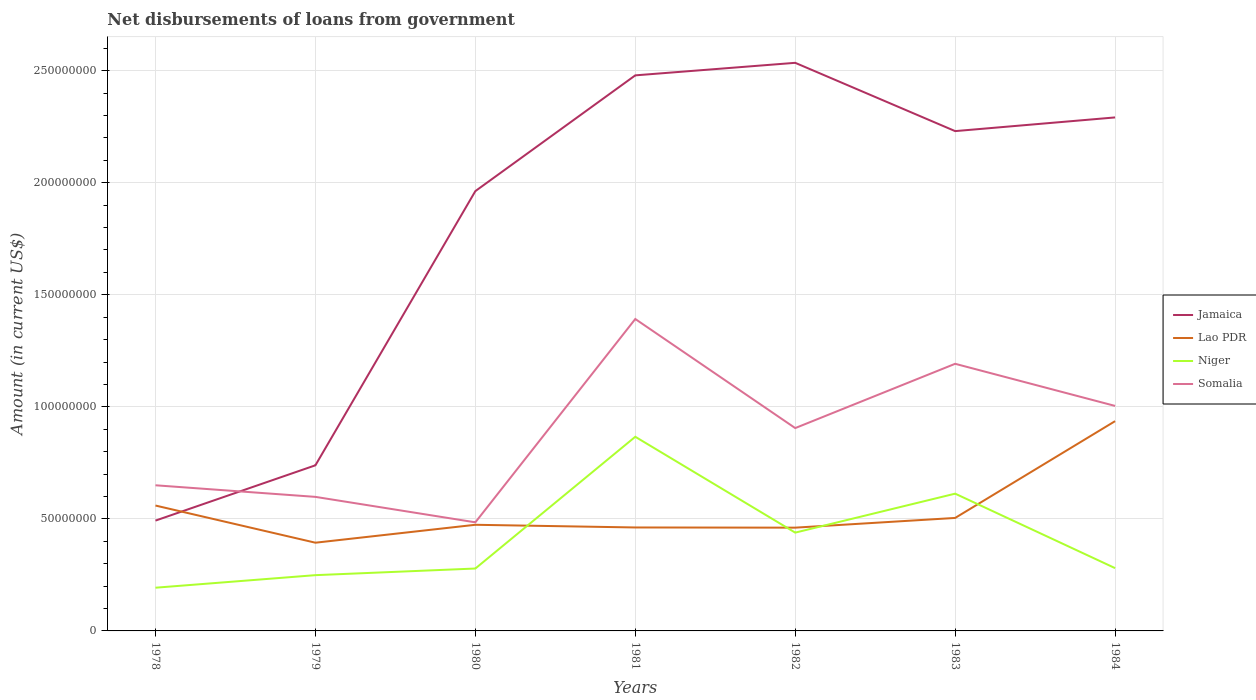Is the number of lines equal to the number of legend labels?
Offer a terse response. Yes. Across all years, what is the maximum amount of loan disbursed from government in Jamaica?
Your response must be concise. 4.92e+07. In which year was the amount of loan disbursed from government in Somalia maximum?
Give a very brief answer. 1980. What is the total amount of loan disbursed from government in Niger in the graph?
Make the answer very short. -1.60e+07. What is the difference between the highest and the second highest amount of loan disbursed from government in Niger?
Ensure brevity in your answer.  6.74e+07. What is the difference between the highest and the lowest amount of loan disbursed from government in Lao PDR?
Provide a succinct answer. 2. What is the difference between two consecutive major ticks on the Y-axis?
Offer a terse response. 5.00e+07. Does the graph contain any zero values?
Offer a terse response. No. Does the graph contain grids?
Offer a terse response. Yes. Where does the legend appear in the graph?
Your answer should be compact. Center right. How many legend labels are there?
Provide a short and direct response. 4. What is the title of the graph?
Offer a terse response. Net disbursements of loans from government. What is the label or title of the X-axis?
Your answer should be compact. Years. What is the Amount (in current US$) of Jamaica in 1978?
Ensure brevity in your answer.  4.92e+07. What is the Amount (in current US$) of Lao PDR in 1978?
Give a very brief answer. 5.60e+07. What is the Amount (in current US$) of Niger in 1978?
Ensure brevity in your answer.  1.93e+07. What is the Amount (in current US$) in Somalia in 1978?
Ensure brevity in your answer.  6.50e+07. What is the Amount (in current US$) in Jamaica in 1979?
Give a very brief answer. 7.39e+07. What is the Amount (in current US$) of Lao PDR in 1979?
Give a very brief answer. 3.94e+07. What is the Amount (in current US$) in Niger in 1979?
Provide a short and direct response. 2.49e+07. What is the Amount (in current US$) in Somalia in 1979?
Make the answer very short. 5.98e+07. What is the Amount (in current US$) of Jamaica in 1980?
Your answer should be very brief. 1.96e+08. What is the Amount (in current US$) in Lao PDR in 1980?
Offer a terse response. 4.74e+07. What is the Amount (in current US$) in Niger in 1980?
Give a very brief answer. 2.78e+07. What is the Amount (in current US$) of Somalia in 1980?
Keep it short and to the point. 4.85e+07. What is the Amount (in current US$) of Jamaica in 1981?
Keep it short and to the point. 2.48e+08. What is the Amount (in current US$) in Lao PDR in 1981?
Give a very brief answer. 4.62e+07. What is the Amount (in current US$) in Niger in 1981?
Provide a short and direct response. 8.66e+07. What is the Amount (in current US$) of Somalia in 1981?
Provide a short and direct response. 1.39e+08. What is the Amount (in current US$) in Jamaica in 1982?
Provide a succinct answer. 2.54e+08. What is the Amount (in current US$) of Lao PDR in 1982?
Make the answer very short. 4.61e+07. What is the Amount (in current US$) of Niger in 1982?
Ensure brevity in your answer.  4.39e+07. What is the Amount (in current US$) of Somalia in 1982?
Your answer should be very brief. 9.05e+07. What is the Amount (in current US$) in Jamaica in 1983?
Offer a very short reply. 2.23e+08. What is the Amount (in current US$) in Lao PDR in 1983?
Your answer should be very brief. 5.04e+07. What is the Amount (in current US$) of Niger in 1983?
Keep it short and to the point. 6.13e+07. What is the Amount (in current US$) in Somalia in 1983?
Offer a very short reply. 1.19e+08. What is the Amount (in current US$) in Jamaica in 1984?
Offer a terse response. 2.29e+08. What is the Amount (in current US$) in Lao PDR in 1984?
Keep it short and to the point. 9.36e+07. What is the Amount (in current US$) in Niger in 1984?
Offer a very short reply. 2.80e+07. What is the Amount (in current US$) in Somalia in 1984?
Your answer should be very brief. 1.00e+08. Across all years, what is the maximum Amount (in current US$) in Jamaica?
Your response must be concise. 2.54e+08. Across all years, what is the maximum Amount (in current US$) in Lao PDR?
Provide a succinct answer. 9.36e+07. Across all years, what is the maximum Amount (in current US$) in Niger?
Give a very brief answer. 8.66e+07. Across all years, what is the maximum Amount (in current US$) in Somalia?
Provide a short and direct response. 1.39e+08. Across all years, what is the minimum Amount (in current US$) of Jamaica?
Provide a short and direct response. 4.92e+07. Across all years, what is the minimum Amount (in current US$) in Lao PDR?
Offer a terse response. 3.94e+07. Across all years, what is the minimum Amount (in current US$) in Niger?
Offer a very short reply. 1.93e+07. Across all years, what is the minimum Amount (in current US$) in Somalia?
Ensure brevity in your answer.  4.85e+07. What is the total Amount (in current US$) in Jamaica in the graph?
Your response must be concise. 1.27e+09. What is the total Amount (in current US$) in Lao PDR in the graph?
Keep it short and to the point. 3.79e+08. What is the total Amount (in current US$) of Niger in the graph?
Offer a very short reply. 2.92e+08. What is the total Amount (in current US$) in Somalia in the graph?
Ensure brevity in your answer.  6.23e+08. What is the difference between the Amount (in current US$) of Jamaica in 1978 and that in 1979?
Keep it short and to the point. -2.47e+07. What is the difference between the Amount (in current US$) in Lao PDR in 1978 and that in 1979?
Keep it short and to the point. 1.66e+07. What is the difference between the Amount (in current US$) in Niger in 1978 and that in 1979?
Make the answer very short. -5.60e+06. What is the difference between the Amount (in current US$) of Somalia in 1978 and that in 1979?
Offer a terse response. 5.17e+06. What is the difference between the Amount (in current US$) in Jamaica in 1978 and that in 1980?
Keep it short and to the point. -1.47e+08. What is the difference between the Amount (in current US$) of Lao PDR in 1978 and that in 1980?
Your answer should be compact. 8.59e+06. What is the difference between the Amount (in current US$) in Niger in 1978 and that in 1980?
Provide a short and direct response. -8.56e+06. What is the difference between the Amount (in current US$) of Somalia in 1978 and that in 1980?
Your answer should be very brief. 1.65e+07. What is the difference between the Amount (in current US$) in Jamaica in 1978 and that in 1981?
Your answer should be compact. -1.99e+08. What is the difference between the Amount (in current US$) in Lao PDR in 1978 and that in 1981?
Keep it short and to the point. 9.79e+06. What is the difference between the Amount (in current US$) in Niger in 1978 and that in 1981?
Provide a succinct answer. -6.74e+07. What is the difference between the Amount (in current US$) of Somalia in 1978 and that in 1981?
Make the answer very short. -7.42e+07. What is the difference between the Amount (in current US$) of Jamaica in 1978 and that in 1982?
Ensure brevity in your answer.  -2.04e+08. What is the difference between the Amount (in current US$) in Lao PDR in 1978 and that in 1982?
Offer a very short reply. 9.87e+06. What is the difference between the Amount (in current US$) in Niger in 1978 and that in 1982?
Ensure brevity in your answer.  -2.46e+07. What is the difference between the Amount (in current US$) in Somalia in 1978 and that in 1982?
Provide a succinct answer. -2.55e+07. What is the difference between the Amount (in current US$) in Jamaica in 1978 and that in 1983?
Offer a terse response. -1.74e+08. What is the difference between the Amount (in current US$) in Lao PDR in 1978 and that in 1983?
Your answer should be very brief. 5.54e+06. What is the difference between the Amount (in current US$) in Niger in 1978 and that in 1983?
Provide a short and direct response. -4.20e+07. What is the difference between the Amount (in current US$) in Somalia in 1978 and that in 1983?
Ensure brevity in your answer.  -5.42e+07. What is the difference between the Amount (in current US$) of Jamaica in 1978 and that in 1984?
Provide a succinct answer. -1.80e+08. What is the difference between the Amount (in current US$) in Lao PDR in 1978 and that in 1984?
Make the answer very short. -3.77e+07. What is the difference between the Amount (in current US$) in Niger in 1978 and that in 1984?
Provide a succinct answer. -8.74e+06. What is the difference between the Amount (in current US$) in Somalia in 1978 and that in 1984?
Keep it short and to the point. -3.54e+07. What is the difference between the Amount (in current US$) in Jamaica in 1979 and that in 1980?
Offer a terse response. -1.22e+08. What is the difference between the Amount (in current US$) in Lao PDR in 1979 and that in 1980?
Your response must be concise. -8.00e+06. What is the difference between the Amount (in current US$) in Niger in 1979 and that in 1980?
Your answer should be compact. -2.96e+06. What is the difference between the Amount (in current US$) in Somalia in 1979 and that in 1980?
Offer a very short reply. 1.14e+07. What is the difference between the Amount (in current US$) in Jamaica in 1979 and that in 1981?
Make the answer very short. -1.74e+08. What is the difference between the Amount (in current US$) in Lao PDR in 1979 and that in 1981?
Your response must be concise. -6.80e+06. What is the difference between the Amount (in current US$) of Niger in 1979 and that in 1981?
Offer a very short reply. -6.18e+07. What is the difference between the Amount (in current US$) of Somalia in 1979 and that in 1981?
Offer a very short reply. -7.94e+07. What is the difference between the Amount (in current US$) in Jamaica in 1979 and that in 1982?
Keep it short and to the point. -1.80e+08. What is the difference between the Amount (in current US$) in Lao PDR in 1979 and that in 1982?
Make the answer very short. -6.72e+06. What is the difference between the Amount (in current US$) of Niger in 1979 and that in 1982?
Your answer should be compact. -1.90e+07. What is the difference between the Amount (in current US$) of Somalia in 1979 and that in 1982?
Offer a very short reply. -3.07e+07. What is the difference between the Amount (in current US$) of Jamaica in 1979 and that in 1983?
Give a very brief answer. -1.49e+08. What is the difference between the Amount (in current US$) in Lao PDR in 1979 and that in 1983?
Your answer should be compact. -1.11e+07. What is the difference between the Amount (in current US$) of Niger in 1979 and that in 1983?
Give a very brief answer. -3.64e+07. What is the difference between the Amount (in current US$) in Somalia in 1979 and that in 1983?
Provide a succinct answer. -5.94e+07. What is the difference between the Amount (in current US$) in Jamaica in 1979 and that in 1984?
Give a very brief answer. -1.55e+08. What is the difference between the Amount (in current US$) of Lao PDR in 1979 and that in 1984?
Make the answer very short. -5.42e+07. What is the difference between the Amount (in current US$) in Niger in 1979 and that in 1984?
Make the answer very short. -3.14e+06. What is the difference between the Amount (in current US$) in Somalia in 1979 and that in 1984?
Provide a succinct answer. -4.06e+07. What is the difference between the Amount (in current US$) in Jamaica in 1980 and that in 1981?
Provide a succinct answer. -5.17e+07. What is the difference between the Amount (in current US$) of Lao PDR in 1980 and that in 1981?
Offer a very short reply. 1.20e+06. What is the difference between the Amount (in current US$) in Niger in 1980 and that in 1981?
Offer a terse response. -5.88e+07. What is the difference between the Amount (in current US$) in Somalia in 1980 and that in 1981?
Your answer should be very brief. -9.07e+07. What is the difference between the Amount (in current US$) in Jamaica in 1980 and that in 1982?
Make the answer very short. -5.73e+07. What is the difference between the Amount (in current US$) in Lao PDR in 1980 and that in 1982?
Make the answer very short. 1.28e+06. What is the difference between the Amount (in current US$) of Niger in 1980 and that in 1982?
Offer a terse response. -1.60e+07. What is the difference between the Amount (in current US$) in Somalia in 1980 and that in 1982?
Offer a terse response. -4.21e+07. What is the difference between the Amount (in current US$) in Jamaica in 1980 and that in 1983?
Make the answer very short. -2.68e+07. What is the difference between the Amount (in current US$) in Lao PDR in 1980 and that in 1983?
Give a very brief answer. -3.05e+06. What is the difference between the Amount (in current US$) in Niger in 1980 and that in 1983?
Give a very brief answer. -3.34e+07. What is the difference between the Amount (in current US$) of Somalia in 1980 and that in 1983?
Your answer should be very brief. -7.07e+07. What is the difference between the Amount (in current US$) in Jamaica in 1980 and that in 1984?
Provide a short and direct response. -3.29e+07. What is the difference between the Amount (in current US$) in Lao PDR in 1980 and that in 1984?
Ensure brevity in your answer.  -4.62e+07. What is the difference between the Amount (in current US$) in Niger in 1980 and that in 1984?
Offer a very short reply. -1.76e+05. What is the difference between the Amount (in current US$) of Somalia in 1980 and that in 1984?
Ensure brevity in your answer.  -5.19e+07. What is the difference between the Amount (in current US$) in Jamaica in 1981 and that in 1982?
Offer a terse response. -5.60e+06. What is the difference between the Amount (in current US$) of Lao PDR in 1981 and that in 1982?
Provide a succinct answer. 8.10e+04. What is the difference between the Amount (in current US$) in Niger in 1981 and that in 1982?
Your answer should be compact. 4.28e+07. What is the difference between the Amount (in current US$) of Somalia in 1981 and that in 1982?
Provide a short and direct response. 4.87e+07. What is the difference between the Amount (in current US$) in Jamaica in 1981 and that in 1983?
Your answer should be very brief. 2.49e+07. What is the difference between the Amount (in current US$) of Lao PDR in 1981 and that in 1983?
Offer a terse response. -4.25e+06. What is the difference between the Amount (in current US$) in Niger in 1981 and that in 1983?
Provide a short and direct response. 2.54e+07. What is the difference between the Amount (in current US$) in Somalia in 1981 and that in 1983?
Give a very brief answer. 2.00e+07. What is the difference between the Amount (in current US$) in Jamaica in 1981 and that in 1984?
Keep it short and to the point. 1.88e+07. What is the difference between the Amount (in current US$) in Lao PDR in 1981 and that in 1984?
Provide a short and direct response. -4.74e+07. What is the difference between the Amount (in current US$) of Niger in 1981 and that in 1984?
Make the answer very short. 5.86e+07. What is the difference between the Amount (in current US$) of Somalia in 1981 and that in 1984?
Offer a very short reply. 3.88e+07. What is the difference between the Amount (in current US$) of Jamaica in 1982 and that in 1983?
Offer a very short reply. 3.05e+07. What is the difference between the Amount (in current US$) in Lao PDR in 1982 and that in 1983?
Keep it short and to the point. -4.34e+06. What is the difference between the Amount (in current US$) in Niger in 1982 and that in 1983?
Offer a terse response. -1.74e+07. What is the difference between the Amount (in current US$) in Somalia in 1982 and that in 1983?
Your answer should be compact. -2.87e+07. What is the difference between the Amount (in current US$) of Jamaica in 1982 and that in 1984?
Ensure brevity in your answer.  2.44e+07. What is the difference between the Amount (in current US$) in Lao PDR in 1982 and that in 1984?
Your response must be concise. -4.75e+07. What is the difference between the Amount (in current US$) of Niger in 1982 and that in 1984?
Ensure brevity in your answer.  1.58e+07. What is the difference between the Amount (in current US$) of Somalia in 1982 and that in 1984?
Offer a very short reply. -9.89e+06. What is the difference between the Amount (in current US$) in Jamaica in 1983 and that in 1984?
Give a very brief answer. -6.11e+06. What is the difference between the Amount (in current US$) in Lao PDR in 1983 and that in 1984?
Your answer should be very brief. -4.32e+07. What is the difference between the Amount (in current US$) of Niger in 1983 and that in 1984?
Ensure brevity in your answer.  3.32e+07. What is the difference between the Amount (in current US$) in Somalia in 1983 and that in 1984?
Your answer should be compact. 1.88e+07. What is the difference between the Amount (in current US$) in Jamaica in 1978 and the Amount (in current US$) in Lao PDR in 1979?
Your answer should be very brief. 9.86e+06. What is the difference between the Amount (in current US$) of Jamaica in 1978 and the Amount (in current US$) of Niger in 1979?
Your response must be concise. 2.43e+07. What is the difference between the Amount (in current US$) of Jamaica in 1978 and the Amount (in current US$) of Somalia in 1979?
Make the answer very short. -1.06e+07. What is the difference between the Amount (in current US$) of Lao PDR in 1978 and the Amount (in current US$) of Niger in 1979?
Ensure brevity in your answer.  3.11e+07. What is the difference between the Amount (in current US$) in Lao PDR in 1978 and the Amount (in current US$) in Somalia in 1979?
Offer a very short reply. -3.86e+06. What is the difference between the Amount (in current US$) of Niger in 1978 and the Amount (in current US$) of Somalia in 1979?
Give a very brief answer. -4.05e+07. What is the difference between the Amount (in current US$) of Jamaica in 1978 and the Amount (in current US$) of Lao PDR in 1980?
Your response must be concise. 1.87e+06. What is the difference between the Amount (in current US$) of Jamaica in 1978 and the Amount (in current US$) of Niger in 1980?
Give a very brief answer. 2.14e+07. What is the difference between the Amount (in current US$) in Jamaica in 1978 and the Amount (in current US$) in Somalia in 1980?
Provide a short and direct response. 7.70e+05. What is the difference between the Amount (in current US$) of Lao PDR in 1978 and the Amount (in current US$) of Niger in 1980?
Provide a short and direct response. 2.81e+07. What is the difference between the Amount (in current US$) of Lao PDR in 1978 and the Amount (in current US$) of Somalia in 1980?
Provide a succinct answer. 7.49e+06. What is the difference between the Amount (in current US$) in Niger in 1978 and the Amount (in current US$) in Somalia in 1980?
Keep it short and to the point. -2.92e+07. What is the difference between the Amount (in current US$) of Jamaica in 1978 and the Amount (in current US$) of Lao PDR in 1981?
Make the answer very short. 3.07e+06. What is the difference between the Amount (in current US$) in Jamaica in 1978 and the Amount (in current US$) in Niger in 1981?
Offer a terse response. -3.74e+07. What is the difference between the Amount (in current US$) of Jamaica in 1978 and the Amount (in current US$) of Somalia in 1981?
Your answer should be compact. -9.00e+07. What is the difference between the Amount (in current US$) in Lao PDR in 1978 and the Amount (in current US$) in Niger in 1981?
Your response must be concise. -3.07e+07. What is the difference between the Amount (in current US$) of Lao PDR in 1978 and the Amount (in current US$) of Somalia in 1981?
Your response must be concise. -8.32e+07. What is the difference between the Amount (in current US$) of Niger in 1978 and the Amount (in current US$) of Somalia in 1981?
Ensure brevity in your answer.  -1.20e+08. What is the difference between the Amount (in current US$) in Jamaica in 1978 and the Amount (in current US$) in Lao PDR in 1982?
Provide a short and direct response. 3.15e+06. What is the difference between the Amount (in current US$) in Jamaica in 1978 and the Amount (in current US$) in Niger in 1982?
Your answer should be compact. 5.36e+06. What is the difference between the Amount (in current US$) in Jamaica in 1978 and the Amount (in current US$) in Somalia in 1982?
Provide a short and direct response. -4.13e+07. What is the difference between the Amount (in current US$) of Lao PDR in 1978 and the Amount (in current US$) of Niger in 1982?
Make the answer very short. 1.21e+07. What is the difference between the Amount (in current US$) of Lao PDR in 1978 and the Amount (in current US$) of Somalia in 1982?
Your response must be concise. -3.46e+07. What is the difference between the Amount (in current US$) of Niger in 1978 and the Amount (in current US$) of Somalia in 1982?
Make the answer very short. -7.12e+07. What is the difference between the Amount (in current US$) of Jamaica in 1978 and the Amount (in current US$) of Lao PDR in 1983?
Give a very brief answer. -1.19e+06. What is the difference between the Amount (in current US$) of Jamaica in 1978 and the Amount (in current US$) of Niger in 1983?
Keep it short and to the point. -1.20e+07. What is the difference between the Amount (in current US$) of Jamaica in 1978 and the Amount (in current US$) of Somalia in 1983?
Keep it short and to the point. -7.00e+07. What is the difference between the Amount (in current US$) of Lao PDR in 1978 and the Amount (in current US$) of Niger in 1983?
Offer a terse response. -5.30e+06. What is the difference between the Amount (in current US$) of Lao PDR in 1978 and the Amount (in current US$) of Somalia in 1983?
Provide a short and direct response. -6.33e+07. What is the difference between the Amount (in current US$) in Niger in 1978 and the Amount (in current US$) in Somalia in 1983?
Provide a succinct answer. -9.99e+07. What is the difference between the Amount (in current US$) in Jamaica in 1978 and the Amount (in current US$) in Lao PDR in 1984?
Offer a very short reply. -4.44e+07. What is the difference between the Amount (in current US$) of Jamaica in 1978 and the Amount (in current US$) of Niger in 1984?
Provide a succinct answer. 2.12e+07. What is the difference between the Amount (in current US$) in Jamaica in 1978 and the Amount (in current US$) in Somalia in 1984?
Keep it short and to the point. -5.12e+07. What is the difference between the Amount (in current US$) of Lao PDR in 1978 and the Amount (in current US$) of Niger in 1984?
Your response must be concise. 2.79e+07. What is the difference between the Amount (in current US$) of Lao PDR in 1978 and the Amount (in current US$) of Somalia in 1984?
Offer a terse response. -4.45e+07. What is the difference between the Amount (in current US$) in Niger in 1978 and the Amount (in current US$) in Somalia in 1984?
Ensure brevity in your answer.  -8.11e+07. What is the difference between the Amount (in current US$) of Jamaica in 1979 and the Amount (in current US$) of Lao PDR in 1980?
Give a very brief answer. 2.65e+07. What is the difference between the Amount (in current US$) in Jamaica in 1979 and the Amount (in current US$) in Niger in 1980?
Offer a terse response. 4.61e+07. What is the difference between the Amount (in current US$) of Jamaica in 1979 and the Amount (in current US$) of Somalia in 1980?
Offer a terse response. 2.54e+07. What is the difference between the Amount (in current US$) in Lao PDR in 1979 and the Amount (in current US$) in Niger in 1980?
Your answer should be compact. 1.15e+07. What is the difference between the Amount (in current US$) in Lao PDR in 1979 and the Amount (in current US$) in Somalia in 1980?
Offer a terse response. -9.09e+06. What is the difference between the Amount (in current US$) of Niger in 1979 and the Amount (in current US$) of Somalia in 1980?
Ensure brevity in your answer.  -2.36e+07. What is the difference between the Amount (in current US$) of Jamaica in 1979 and the Amount (in current US$) of Lao PDR in 1981?
Your answer should be very brief. 2.77e+07. What is the difference between the Amount (in current US$) of Jamaica in 1979 and the Amount (in current US$) of Niger in 1981?
Offer a terse response. -1.27e+07. What is the difference between the Amount (in current US$) of Jamaica in 1979 and the Amount (in current US$) of Somalia in 1981?
Your answer should be very brief. -6.53e+07. What is the difference between the Amount (in current US$) of Lao PDR in 1979 and the Amount (in current US$) of Niger in 1981?
Provide a short and direct response. -4.73e+07. What is the difference between the Amount (in current US$) of Lao PDR in 1979 and the Amount (in current US$) of Somalia in 1981?
Offer a very short reply. -9.98e+07. What is the difference between the Amount (in current US$) of Niger in 1979 and the Amount (in current US$) of Somalia in 1981?
Ensure brevity in your answer.  -1.14e+08. What is the difference between the Amount (in current US$) in Jamaica in 1979 and the Amount (in current US$) in Lao PDR in 1982?
Offer a terse response. 2.78e+07. What is the difference between the Amount (in current US$) in Jamaica in 1979 and the Amount (in current US$) in Niger in 1982?
Provide a succinct answer. 3.00e+07. What is the difference between the Amount (in current US$) of Jamaica in 1979 and the Amount (in current US$) of Somalia in 1982?
Your response must be concise. -1.66e+07. What is the difference between the Amount (in current US$) in Lao PDR in 1979 and the Amount (in current US$) in Niger in 1982?
Your answer should be compact. -4.50e+06. What is the difference between the Amount (in current US$) in Lao PDR in 1979 and the Amount (in current US$) in Somalia in 1982?
Provide a succinct answer. -5.12e+07. What is the difference between the Amount (in current US$) in Niger in 1979 and the Amount (in current US$) in Somalia in 1982?
Offer a terse response. -6.56e+07. What is the difference between the Amount (in current US$) of Jamaica in 1979 and the Amount (in current US$) of Lao PDR in 1983?
Keep it short and to the point. 2.35e+07. What is the difference between the Amount (in current US$) in Jamaica in 1979 and the Amount (in current US$) in Niger in 1983?
Offer a terse response. 1.27e+07. What is the difference between the Amount (in current US$) of Jamaica in 1979 and the Amount (in current US$) of Somalia in 1983?
Offer a very short reply. -4.53e+07. What is the difference between the Amount (in current US$) in Lao PDR in 1979 and the Amount (in current US$) in Niger in 1983?
Keep it short and to the point. -2.19e+07. What is the difference between the Amount (in current US$) in Lao PDR in 1979 and the Amount (in current US$) in Somalia in 1983?
Offer a terse response. -7.98e+07. What is the difference between the Amount (in current US$) in Niger in 1979 and the Amount (in current US$) in Somalia in 1983?
Your response must be concise. -9.43e+07. What is the difference between the Amount (in current US$) in Jamaica in 1979 and the Amount (in current US$) in Lao PDR in 1984?
Your response must be concise. -1.97e+07. What is the difference between the Amount (in current US$) of Jamaica in 1979 and the Amount (in current US$) of Niger in 1984?
Your answer should be very brief. 4.59e+07. What is the difference between the Amount (in current US$) of Jamaica in 1979 and the Amount (in current US$) of Somalia in 1984?
Make the answer very short. -2.65e+07. What is the difference between the Amount (in current US$) of Lao PDR in 1979 and the Amount (in current US$) of Niger in 1984?
Keep it short and to the point. 1.13e+07. What is the difference between the Amount (in current US$) of Lao PDR in 1979 and the Amount (in current US$) of Somalia in 1984?
Offer a terse response. -6.10e+07. What is the difference between the Amount (in current US$) of Niger in 1979 and the Amount (in current US$) of Somalia in 1984?
Keep it short and to the point. -7.55e+07. What is the difference between the Amount (in current US$) of Jamaica in 1980 and the Amount (in current US$) of Lao PDR in 1981?
Your answer should be compact. 1.50e+08. What is the difference between the Amount (in current US$) in Jamaica in 1980 and the Amount (in current US$) in Niger in 1981?
Make the answer very short. 1.10e+08. What is the difference between the Amount (in current US$) of Jamaica in 1980 and the Amount (in current US$) of Somalia in 1981?
Give a very brief answer. 5.71e+07. What is the difference between the Amount (in current US$) in Lao PDR in 1980 and the Amount (in current US$) in Niger in 1981?
Keep it short and to the point. -3.93e+07. What is the difference between the Amount (in current US$) in Lao PDR in 1980 and the Amount (in current US$) in Somalia in 1981?
Give a very brief answer. -9.18e+07. What is the difference between the Amount (in current US$) in Niger in 1980 and the Amount (in current US$) in Somalia in 1981?
Offer a very short reply. -1.11e+08. What is the difference between the Amount (in current US$) in Jamaica in 1980 and the Amount (in current US$) in Lao PDR in 1982?
Your response must be concise. 1.50e+08. What is the difference between the Amount (in current US$) of Jamaica in 1980 and the Amount (in current US$) of Niger in 1982?
Your answer should be compact. 1.52e+08. What is the difference between the Amount (in current US$) of Jamaica in 1980 and the Amount (in current US$) of Somalia in 1982?
Your response must be concise. 1.06e+08. What is the difference between the Amount (in current US$) of Lao PDR in 1980 and the Amount (in current US$) of Niger in 1982?
Provide a succinct answer. 3.50e+06. What is the difference between the Amount (in current US$) of Lao PDR in 1980 and the Amount (in current US$) of Somalia in 1982?
Offer a terse response. -4.32e+07. What is the difference between the Amount (in current US$) in Niger in 1980 and the Amount (in current US$) in Somalia in 1982?
Provide a short and direct response. -6.27e+07. What is the difference between the Amount (in current US$) of Jamaica in 1980 and the Amount (in current US$) of Lao PDR in 1983?
Make the answer very short. 1.46e+08. What is the difference between the Amount (in current US$) of Jamaica in 1980 and the Amount (in current US$) of Niger in 1983?
Give a very brief answer. 1.35e+08. What is the difference between the Amount (in current US$) of Jamaica in 1980 and the Amount (in current US$) of Somalia in 1983?
Your response must be concise. 7.71e+07. What is the difference between the Amount (in current US$) of Lao PDR in 1980 and the Amount (in current US$) of Niger in 1983?
Make the answer very short. -1.39e+07. What is the difference between the Amount (in current US$) in Lao PDR in 1980 and the Amount (in current US$) in Somalia in 1983?
Provide a succinct answer. -7.18e+07. What is the difference between the Amount (in current US$) in Niger in 1980 and the Amount (in current US$) in Somalia in 1983?
Your answer should be compact. -9.14e+07. What is the difference between the Amount (in current US$) in Jamaica in 1980 and the Amount (in current US$) in Lao PDR in 1984?
Offer a terse response. 1.03e+08. What is the difference between the Amount (in current US$) in Jamaica in 1980 and the Amount (in current US$) in Niger in 1984?
Offer a terse response. 1.68e+08. What is the difference between the Amount (in current US$) of Jamaica in 1980 and the Amount (in current US$) of Somalia in 1984?
Ensure brevity in your answer.  9.59e+07. What is the difference between the Amount (in current US$) in Lao PDR in 1980 and the Amount (in current US$) in Niger in 1984?
Provide a short and direct response. 1.93e+07. What is the difference between the Amount (in current US$) in Lao PDR in 1980 and the Amount (in current US$) in Somalia in 1984?
Provide a succinct answer. -5.30e+07. What is the difference between the Amount (in current US$) of Niger in 1980 and the Amount (in current US$) of Somalia in 1984?
Provide a succinct answer. -7.26e+07. What is the difference between the Amount (in current US$) of Jamaica in 1981 and the Amount (in current US$) of Lao PDR in 1982?
Offer a very short reply. 2.02e+08. What is the difference between the Amount (in current US$) of Jamaica in 1981 and the Amount (in current US$) of Niger in 1982?
Provide a short and direct response. 2.04e+08. What is the difference between the Amount (in current US$) in Jamaica in 1981 and the Amount (in current US$) in Somalia in 1982?
Provide a short and direct response. 1.57e+08. What is the difference between the Amount (in current US$) of Lao PDR in 1981 and the Amount (in current US$) of Niger in 1982?
Ensure brevity in your answer.  2.30e+06. What is the difference between the Amount (in current US$) of Lao PDR in 1981 and the Amount (in current US$) of Somalia in 1982?
Provide a short and direct response. -4.44e+07. What is the difference between the Amount (in current US$) in Niger in 1981 and the Amount (in current US$) in Somalia in 1982?
Offer a terse response. -3.87e+06. What is the difference between the Amount (in current US$) in Jamaica in 1981 and the Amount (in current US$) in Lao PDR in 1983?
Give a very brief answer. 1.98e+08. What is the difference between the Amount (in current US$) in Jamaica in 1981 and the Amount (in current US$) in Niger in 1983?
Offer a very short reply. 1.87e+08. What is the difference between the Amount (in current US$) in Jamaica in 1981 and the Amount (in current US$) in Somalia in 1983?
Your answer should be very brief. 1.29e+08. What is the difference between the Amount (in current US$) in Lao PDR in 1981 and the Amount (in current US$) in Niger in 1983?
Keep it short and to the point. -1.51e+07. What is the difference between the Amount (in current US$) of Lao PDR in 1981 and the Amount (in current US$) of Somalia in 1983?
Provide a short and direct response. -7.30e+07. What is the difference between the Amount (in current US$) in Niger in 1981 and the Amount (in current US$) in Somalia in 1983?
Give a very brief answer. -3.26e+07. What is the difference between the Amount (in current US$) of Jamaica in 1981 and the Amount (in current US$) of Lao PDR in 1984?
Make the answer very short. 1.54e+08. What is the difference between the Amount (in current US$) of Jamaica in 1981 and the Amount (in current US$) of Niger in 1984?
Your response must be concise. 2.20e+08. What is the difference between the Amount (in current US$) in Jamaica in 1981 and the Amount (in current US$) in Somalia in 1984?
Your answer should be compact. 1.48e+08. What is the difference between the Amount (in current US$) of Lao PDR in 1981 and the Amount (in current US$) of Niger in 1984?
Give a very brief answer. 1.81e+07. What is the difference between the Amount (in current US$) of Lao PDR in 1981 and the Amount (in current US$) of Somalia in 1984?
Offer a terse response. -5.42e+07. What is the difference between the Amount (in current US$) in Niger in 1981 and the Amount (in current US$) in Somalia in 1984?
Keep it short and to the point. -1.38e+07. What is the difference between the Amount (in current US$) in Jamaica in 1982 and the Amount (in current US$) in Lao PDR in 1983?
Give a very brief answer. 2.03e+08. What is the difference between the Amount (in current US$) in Jamaica in 1982 and the Amount (in current US$) in Niger in 1983?
Keep it short and to the point. 1.92e+08. What is the difference between the Amount (in current US$) in Jamaica in 1982 and the Amount (in current US$) in Somalia in 1983?
Offer a very short reply. 1.34e+08. What is the difference between the Amount (in current US$) in Lao PDR in 1982 and the Amount (in current US$) in Niger in 1983?
Keep it short and to the point. -1.52e+07. What is the difference between the Amount (in current US$) of Lao PDR in 1982 and the Amount (in current US$) of Somalia in 1983?
Offer a very short reply. -7.31e+07. What is the difference between the Amount (in current US$) of Niger in 1982 and the Amount (in current US$) of Somalia in 1983?
Your answer should be very brief. -7.53e+07. What is the difference between the Amount (in current US$) of Jamaica in 1982 and the Amount (in current US$) of Lao PDR in 1984?
Provide a succinct answer. 1.60e+08. What is the difference between the Amount (in current US$) of Jamaica in 1982 and the Amount (in current US$) of Niger in 1984?
Your answer should be very brief. 2.25e+08. What is the difference between the Amount (in current US$) in Jamaica in 1982 and the Amount (in current US$) in Somalia in 1984?
Make the answer very short. 1.53e+08. What is the difference between the Amount (in current US$) of Lao PDR in 1982 and the Amount (in current US$) of Niger in 1984?
Give a very brief answer. 1.81e+07. What is the difference between the Amount (in current US$) in Lao PDR in 1982 and the Amount (in current US$) in Somalia in 1984?
Your answer should be compact. -5.43e+07. What is the difference between the Amount (in current US$) in Niger in 1982 and the Amount (in current US$) in Somalia in 1984?
Your answer should be compact. -5.65e+07. What is the difference between the Amount (in current US$) of Jamaica in 1983 and the Amount (in current US$) of Lao PDR in 1984?
Offer a very short reply. 1.29e+08. What is the difference between the Amount (in current US$) in Jamaica in 1983 and the Amount (in current US$) in Niger in 1984?
Make the answer very short. 1.95e+08. What is the difference between the Amount (in current US$) in Jamaica in 1983 and the Amount (in current US$) in Somalia in 1984?
Keep it short and to the point. 1.23e+08. What is the difference between the Amount (in current US$) of Lao PDR in 1983 and the Amount (in current US$) of Niger in 1984?
Your answer should be compact. 2.24e+07. What is the difference between the Amount (in current US$) in Lao PDR in 1983 and the Amount (in current US$) in Somalia in 1984?
Your response must be concise. -5.00e+07. What is the difference between the Amount (in current US$) in Niger in 1983 and the Amount (in current US$) in Somalia in 1984?
Offer a very short reply. -3.92e+07. What is the average Amount (in current US$) in Jamaica per year?
Offer a very short reply. 1.82e+08. What is the average Amount (in current US$) of Lao PDR per year?
Your response must be concise. 5.41e+07. What is the average Amount (in current US$) in Niger per year?
Give a very brief answer. 4.17e+07. What is the average Amount (in current US$) in Somalia per year?
Offer a terse response. 8.89e+07. In the year 1978, what is the difference between the Amount (in current US$) of Jamaica and Amount (in current US$) of Lao PDR?
Make the answer very short. -6.72e+06. In the year 1978, what is the difference between the Amount (in current US$) of Jamaica and Amount (in current US$) of Niger?
Offer a very short reply. 2.99e+07. In the year 1978, what is the difference between the Amount (in current US$) in Jamaica and Amount (in current US$) in Somalia?
Your answer should be compact. -1.58e+07. In the year 1978, what is the difference between the Amount (in current US$) in Lao PDR and Amount (in current US$) in Niger?
Your answer should be compact. 3.67e+07. In the year 1978, what is the difference between the Amount (in current US$) in Lao PDR and Amount (in current US$) in Somalia?
Provide a short and direct response. -9.04e+06. In the year 1978, what is the difference between the Amount (in current US$) in Niger and Amount (in current US$) in Somalia?
Provide a short and direct response. -4.57e+07. In the year 1979, what is the difference between the Amount (in current US$) in Jamaica and Amount (in current US$) in Lao PDR?
Provide a succinct answer. 3.45e+07. In the year 1979, what is the difference between the Amount (in current US$) in Jamaica and Amount (in current US$) in Niger?
Your answer should be very brief. 4.90e+07. In the year 1979, what is the difference between the Amount (in current US$) in Jamaica and Amount (in current US$) in Somalia?
Give a very brief answer. 1.41e+07. In the year 1979, what is the difference between the Amount (in current US$) in Lao PDR and Amount (in current US$) in Niger?
Provide a succinct answer. 1.45e+07. In the year 1979, what is the difference between the Amount (in current US$) in Lao PDR and Amount (in current US$) in Somalia?
Keep it short and to the point. -2.05e+07. In the year 1979, what is the difference between the Amount (in current US$) in Niger and Amount (in current US$) in Somalia?
Give a very brief answer. -3.49e+07. In the year 1980, what is the difference between the Amount (in current US$) in Jamaica and Amount (in current US$) in Lao PDR?
Your answer should be very brief. 1.49e+08. In the year 1980, what is the difference between the Amount (in current US$) in Jamaica and Amount (in current US$) in Niger?
Make the answer very short. 1.68e+08. In the year 1980, what is the difference between the Amount (in current US$) in Jamaica and Amount (in current US$) in Somalia?
Your response must be concise. 1.48e+08. In the year 1980, what is the difference between the Amount (in current US$) of Lao PDR and Amount (in current US$) of Niger?
Your answer should be compact. 1.95e+07. In the year 1980, what is the difference between the Amount (in current US$) in Lao PDR and Amount (in current US$) in Somalia?
Offer a terse response. -1.10e+06. In the year 1980, what is the difference between the Amount (in current US$) of Niger and Amount (in current US$) of Somalia?
Your response must be concise. -2.06e+07. In the year 1981, what is the difference between the Amount (in current US$) in Jamaica and Amount (in current US$) in Lao PDR?
Your response must be concise. 2.02e+08. In the year 1981, what is the difference between the Amount (in current US$) of Jamaica and Amount (in current US$) of Niger?
Keep it short and to the point. 1.61e+08. In the year 1981, what is the difference between the Amount (in current US$) of Jamaica and Amount (in current US$) of Somalia?
Offer a very short reply. 1.09e+08. In the year 1981, what is the difference between the Amount (in current US$) in Lao PDR and Amount (in current US$) in Niger?
Offer a very short reply. -4.05e+07. In the year 1981, what is the difference between the Amount (in current US$) in Lao PDR and Amount (in current US$) in Somalia?
Provide a succinct answer. -9.30e+07. In the year 1981, what is the difference between the Amount (in current US$) in Niger and Amount (in current US$) in Somalia?
Keep it short and to the point. -5.26e+07. In the year 1982, what is the difference between the Amount (in current US$) in Jamaica and Amount (in current US$) in Lao PDR?
Provide a succinct answer. 2.07e+08. In the year 1982, what is the difference between the Amount (in current US$) in Jamaica and Amount (in current US$) in Niger?
Provide a short and direct response. 2.10e+08. In the year 1982, what is the difference between the Amount (in current US$) in Jamaica and Amount (in current US$) in Somalia?
Keep it short and to the point. 1.63e+08. In the year 1982, what is the difference between the Amount (in current US$) in Lao PDR and Amount (in current US$) in Niger?
Provide a short and direct response. 2.22e+06. In the year 1982, what is the difference between the Amount (in current US$) of Lao PDR and Amount (in current US$) of Somalia?
Provide a succinct answer. -4.44e+07. In the year 1982, what is the difference between the Amount (in current US$) in Niger and Amount (in current US$) in Somalia?
Provide a short and direct response. -4.66e+07. In the year 1983, what is the difference between the Amount (in current US$) in Jamaica and Amount (in current US$) in Lao PDR?
Provide a succinct answer. 1.73e+08. In the year 1983, what is the difference between the Amount (in current US$) of Jamaica and Amount (in current US$) of Niger?
Your response must be concise. 1.62e+08. In the year 1983, what is the difference between the Amount (in current US$) of Jamaica and Amount (in current US$) of Somalia?
Provide a succinct answer. 1.04e+08. In the year 1983, what is the difference between the Amount (in current US$) in Lao PDR and Amount (in current US$) in Niger?
Provide a succinct answer. -1.08e+07. In the year 1983, what is the difference between the Amount (in current US$) of Lao PDR and Amount (in current US$) of Somalia?
Your answer should be very brief. -6.88e+07. In the year 1983, what is the difference between the Amount (in current US$) of Niger and Amount (in current US$) of Somalia?
Provide a succinct answer. -5.80e+07. In the year 1984, what is the difference between the Amount (in current US$) of Jamaica and Amount (in current US$) of Lao PDR?
Offer a terse response. 1.36e+08. In the year 1984, what is the difference between the Amount (in current US$) in Jamaica and Amount (in current US$) in Niger?
Offer a terse response. 2.01e+08. In the year 1984, what is the difference between the Amount (in current US$) of Jamaica and Amount (in current US$) of Somalia?
Keep it short and to the point. 1.29e+08. In the year 1984, what is the difference between the Amount (in current US$) of Lao PDR and Amount (in current US$) of Niger?
Offer a terse response. 6.56e+07. In the year 1984, what is the difference between the Amount (in current US$) of Lao PDR and Amount (in current US$) of Somalia?
Make the answer very short. -6.80e+06. In the year 1984, what is the difference between the Amount (in current US$) in Niger and Amount (in current US$) in Somalia?
Keep it short and to the point. -7.24e+07. What is the ratio of the Amount (in current US$) in Jamaica in 1978 to that in 1979?
Make the answer very short. 0.67. What is the ratio of the Amount (in current US$) in Lao PDR in 1978 to that in 1979?
Make the answer very short. 1.42. What is the ratio of the Amount (in current US$) in Niger in 1978 to that in 1979?
Make the answer very short. 0.78. What is the ratio of the Amount (in current US$) in Somalia in 1978 to that in 1979?
Your answer should be compact. 1.09. What is the ratio of the Amount (in current US$) in Jamaica in 1978 to that in 1980?
Offer a very short reply. 0.25. What is the ratio of the Amount (in current US$) of Lao PDR in 1978 to that in 1980?
Your response must be concise. 1.18. What is the ratio of the Amount (in current US$) of Niger in 1978 to that in 1980?
Provide a succinct answer. 0.69. What is the ratio of the Amount (in current US$) of Somalia in 1978 to that in 1980?
Offer a terse response. 1.34. What is the ratio of the Amount (in current US$) of Jamaica in 1978 to that in 1981?
Ensure brevity in your answer.  0.2. What is the ratio of the Amount (in current US$) of Lao PDR in 1978 to that in 1981?
Ensure brevity in your answer.  1.21. What is the ratio of the Amount (in current US$) in Niger in 1978 to that in 1981?
Provide a succinct answer. 0.22. What is the ratio of the Amount (in current US$) in Somalia in 1978 to that in 1981?
Provide a succinct answer. 0.47. What is the ratio of the Amount (in current US$) in Jamaica in 1978 to that in 1982?
Your answer should be compact. 0.19. What is the ratio of the Amount (in current US$) of Lao PDR in 1978 to that in 1982?
Offer a terse response. 1.21. What is the ratio of the Amount (in current US$) of Niger in 1978 to that in 1982?
Your response must be concise. 0.44. What is the ratio of the Amount (in current US$) in Somalia in 1978 to that in 1982?
Your answer should be very brief. 0.72. What is the ratio of the Amount (in current US$) of Jamaica in 1978 to that in 1983?
Provide a succinct answer. 0.22. What is the ratio of the Amount (in current US$) of Lao PDR in 1978 to that in 1983?
Make the answer very short. 1.11. What is the ratio of the Amount (in current US$) of Niger in 1978 to that in 1983?
Make the answer very short. 0.31. What is the ratio of the Amount (in current US$) of Somalia in 1978 to that in 1983?
Provide a short and direct response. 0.55. What is the ratio of the Amount (in current US$) in Jamaica in 1978 to that in 1984?
Offer a very short reply. 0.21. What is the ratio of the Amount (in current US$) in Lao PDR in 1978 to that in 1984?
Provide a succinct answer. 0.6. What is the ratio of the Amount (in current US$) of Niger in 1978 to that in 1984?
Provide a short and direct response. 0.69. What is the ratio of the Amount (in current US$) in Somalia in 1978 to that in 1984?
Offer a terse response. 0.65. What is the ratio of the Amount (in current US$) in Jamaica in 1979 to that in 1980?
Make the answer very short. 0.38. What is the ratio of the Amount (in current US$) in Lao PDR in 1979 to that in 1980?
Your answer should be compact. 0.83. What is the ratio of the Amount (in current US$) of Niger in 1979 to that in 1980?
Your response must be concise. 0.89. What is the ratio of the Amount (in current US$) in Somalia in 1979 to that in 1980?
Make the answer very short. 1.23. What is the ratio of the Amount (in current US$) of Jamaica in 1979 to that in 1981?
Offer a very short reply. 0.3. What is the ratio of the Amount (in current US$) in Lao PDR in 1979 to that in 1981?
Offer a very short reply. 0.85. What is the ratio of the Amount (in current US$) in Niger in 1979 to that in 1981?
Provide a short and direct response. 0.29. What is the ratio of the Amount (in current US$) of Somalia in 1979 to that in 1981?
Keep it short and to the point. 0.43. What is the ratio of the Amount (in current US$) in Jamaica in 1979 to that in 1982?
Offer a very short reply. 0.29. What is the ratio of the Amount (in current US$) of Lao PDR in 1979 to that in 1982?
Your response must be concise. 0.85. What is the ratio of the Amount (in current US$) of Niger in 1979 to that in 1982?
Provide a succinct answer. 0.57. What is the ratio of the Amount (in current US$) of Somalia in 1979 to that in 1982?
Keep it short and to the point. 0.66. What is the ratio of the Amount (in current US$) in Jamaica in 1979 to that in 1983?
Ensure brevity in your answer.  0.33. What is the ratio of the Amount (in current US$) of Lao PDR in 1979 to that in 1983?
Provide a short and direct response. 0.78. What is the ratio of the Amount (in current US$) of Niger in 1979 to that in 1983?
Offer a terse response. 0.41. What is the ratio of the Amount (in current US$) in Somalia in 1979 to that in 1983?
Give a very brief answer. 0.5. What is the ratio of the Amount (in current US$) in Jamaica in 1979 to that in 1984?
Make the answer very short. 0.32. What is the ratio of the Amount (in current US$) in Lao PDR in 1979 to that in 1984?
Provide a short and direct response. 0.42. What is the ratio of the Amount (in current US$) of Niger in 1979 to that in 1984?
Provide a short and direct response. 0.89. What is the ratio of the Amount (in current US$) in Somalia in 1979 to that in 1984?
Provide a succinct answer. 0.6. What is the ratio of the Amount (in current US$) of Jamaica in 1980 to that in 1981?
Ensure brevity in your answer.  0.79. What is the ratio of the Amount (in current US$) in Niger in 1980 to that in 1981?
Offer a terse response. 0.32. What is the ratio of the Amount (in current US$) in Somalia in 1980 to that in 1981?
Ensure brevity in your answer.  0.35. What is the ratio of the Amount (in current US$) in Jamaica in 1980 to that in 1982?
Make the answer very short. 0.77. What is the ratio of the Amount (in current US$) of Lao PDR in 1980 to that in 1982?
Provide a short and direct response. 1.03. What is the ratio of the Amount (in current US$) in Niger in 1980 to that in 1982?
Your response must be concise. 0.63. What is the ratio of the Amount (in current US$) of Somalia in 1980 to that in 1982?
Your answer should be very brief. 0.54. What is the ratio of the Amount (in current US$) in Jamaica in 1980 to that in 1983?
Offer a terse response. 0.88. What is the ratio of the Amount (in current US$) in Lao PDR in 1980 to that in 1983?
Make the answer very short. 0.94. What is the ratio of the Amount (in current US$) in Niger in 1980 to that in 1983?
Give a very brief answer. 0.45. What is the ratio of the Amount (in current US$) of Somalia in 1980 to that in 1983?
Your response must be concise. 0.41. What is the ratio of the Amount (in current US$) in Jamaica in 1980 to that in 1984?
Give a very brief answer. 0.86. What is the ratio of the Amount (in current US$) in Lao PDR in 1980 to that in 1984?
Make the answer very short. 0.51. What is the ratio of the Amount (in current US$) in Niger in 1980 to that in 1984?
Your response must be concise. 0.99. What is the ratio of the Amount (in current US$) of Somalia in 1980 to that in 1984?
Provide a short and direct response. 0.48. What is the ratio of the Amount (in current US$) in Jamaica in 1981 to that in 1982?
Ensure brevity in your answer.  0.98. What is the ratio of the Amount (in current US$) of Niger in 1981 to that in 1982?
Make the answer very short. 1.98. What is the ratio of the Amount (in current US$) of Somalia in 1981 to that in 1982?
Your answer should be very brief. 1.54. What is the ratio of the Amount (in current US$) in Jamaica in 1981 to that in 1983?
Make the answer very short. 1.11. What is the ratio of the Amount (in current US$) in Lao PDR in 1981 to that in 1983?
Make the answer very short. 0.92. What is the ratio of the Amount (in current US$) of Niger in 1981 to that in 1983?
Offer a very short reply. 1.41. What is the ratio of the Amount (in current US$) of Somalia in 1981 to that in 1983?
Provide a succinct answer. 1.17. What is the ratio of the Amount (in current US$) of Jamaica in 1981 to that in 1984?
Make the answer very short. 1.08. What is the ratio of the Amount (in current US$) in Lao PDR in 1981 to that in 1984?
Offer a terse response. 0.49. What is the ratio of the Amount (in current US$) in Niger in 1981 to that in 1984?
Keep it short and to the point. 3.09. What is the ratio of the Amount (in current US$) in Somalia in 1981 to that in 1984?
Keep it short and to the point. 1.39. What is the ratio of the Amount (in current US$) in Jamaica in 1982 to that in 1983?
Offer a terse response. 1.14. What is the ratio of the Amount (in current US$) of Lao PDR in 1982 to that in 1983?
Offer a very short reply. 0.91. What is the ratio of the Amount (in current US$) of Niger in 1982 to that in 1983?
Offer a terse response. 0.72. What is the ratio of the Amount (in current US$) in Somalia in 1982 to that in 1983?
Offer a terse response. 0.76. What is the ratio of the Amount (in current US$) of Jamaica in 1982 to that in 1984?
Offer a very short reply. 1.11. What is the ratio of the Amount (in current US$) in Lao PDR in 1982 to that in 1984?
Provide a succinct answer. 0.49. What is the ratio of the Amount (in current US$) of Niger in 1982 to that in 1984?
Provide a succinct answer. 1.57. What is the ratio of the Amount (in current US$) of Somalia in 1982 to that in 1984?
Your response must be concise. 0.9. What is the ratio of the Amount (in current US$) in Jamaica in 1983 to that in 1984?
Offer a terse response. 0.97. What is the ratio of the Amount (in current US$) in Lao PDR in 1983 to that in 1984?
Keep it short and to the point. 0.54. What is the ratio of the Amount (in current US$) in Niger in 1983 to that in 1984?
Give a very brief answer. 2.19. What is the ratio of the Amount (in current US$) in Somalia in 1983 to that in 1984?
Provide a short and direct response. 1.19. What is the difference between the highest and the second highest Amount (in current US$) of Jamaica?
Provide a short and direct response. 5.60e+06. What is the difference between the highest and the second highest Amount (in current US$) of Lao PDR?
Provide a succinct answer. 3.77e+07. What is the difference between the highest and the second highest Amount (in current US$) in Niger?
Your answer should be compact. 2.54e+07. What is the difference between the highest and the second highest Amount (in current US$) of Somalia?
Make the answer very short. 2.00e+07. What is the difference between the highest and the lowest Amount (in current US$) of Jamaica?
Provide a short and direct response. 2.04e+08. What is the difference between the highest and the lowest Amount (in current US$) of Lao PDR?
Provide a succinct answer. 5.42e+07. What is the difference between the highest and the lowest Amount (in current US$) of Niger?
Offer a terse response. 6.74e+07. What is the difference between the highest and the lowest Amount (in current US$) of Somalia?
Keep it short and to the point. 9.07e+07. 